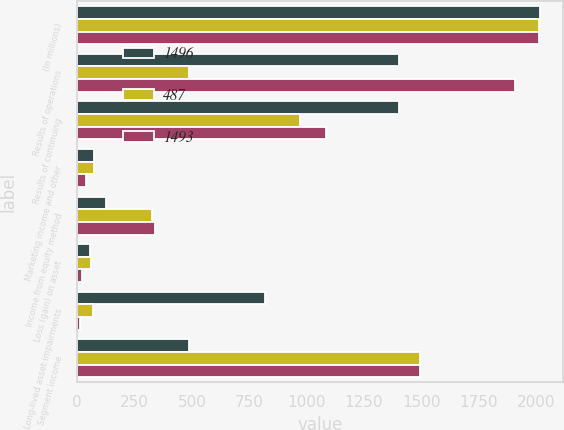Convert chart. <chart><loc_0><loc_0><loc_500><loc_500><stacked_bar_chart><ecel><fcel>(In millions)<fcel>Results of operations<fcel>Results of continuing<fcel>Marketing income and other<fcel>Income from equity method<fcel>Loss (gain) on asset<fcel>Long-lived asset impairments<fcel>Segment income<nl><fcel>1496<fcel>2015<fcel>1404<fcel>1404<fcel>75<fcel>127<fcel>57<fcel>819<fcel>487<nl><fcel>487<fcel>2014<fcel>487<fcel>969<fcel>73<fcel>327<fcel>58<fcel>69<fcel>1496<nl><fcel>1493<fcel>2013<fcel>1906<fcel>1083<fcel>40<fcel>340<fcel>20<fcel>10<fcel>1493<nl></chart> 